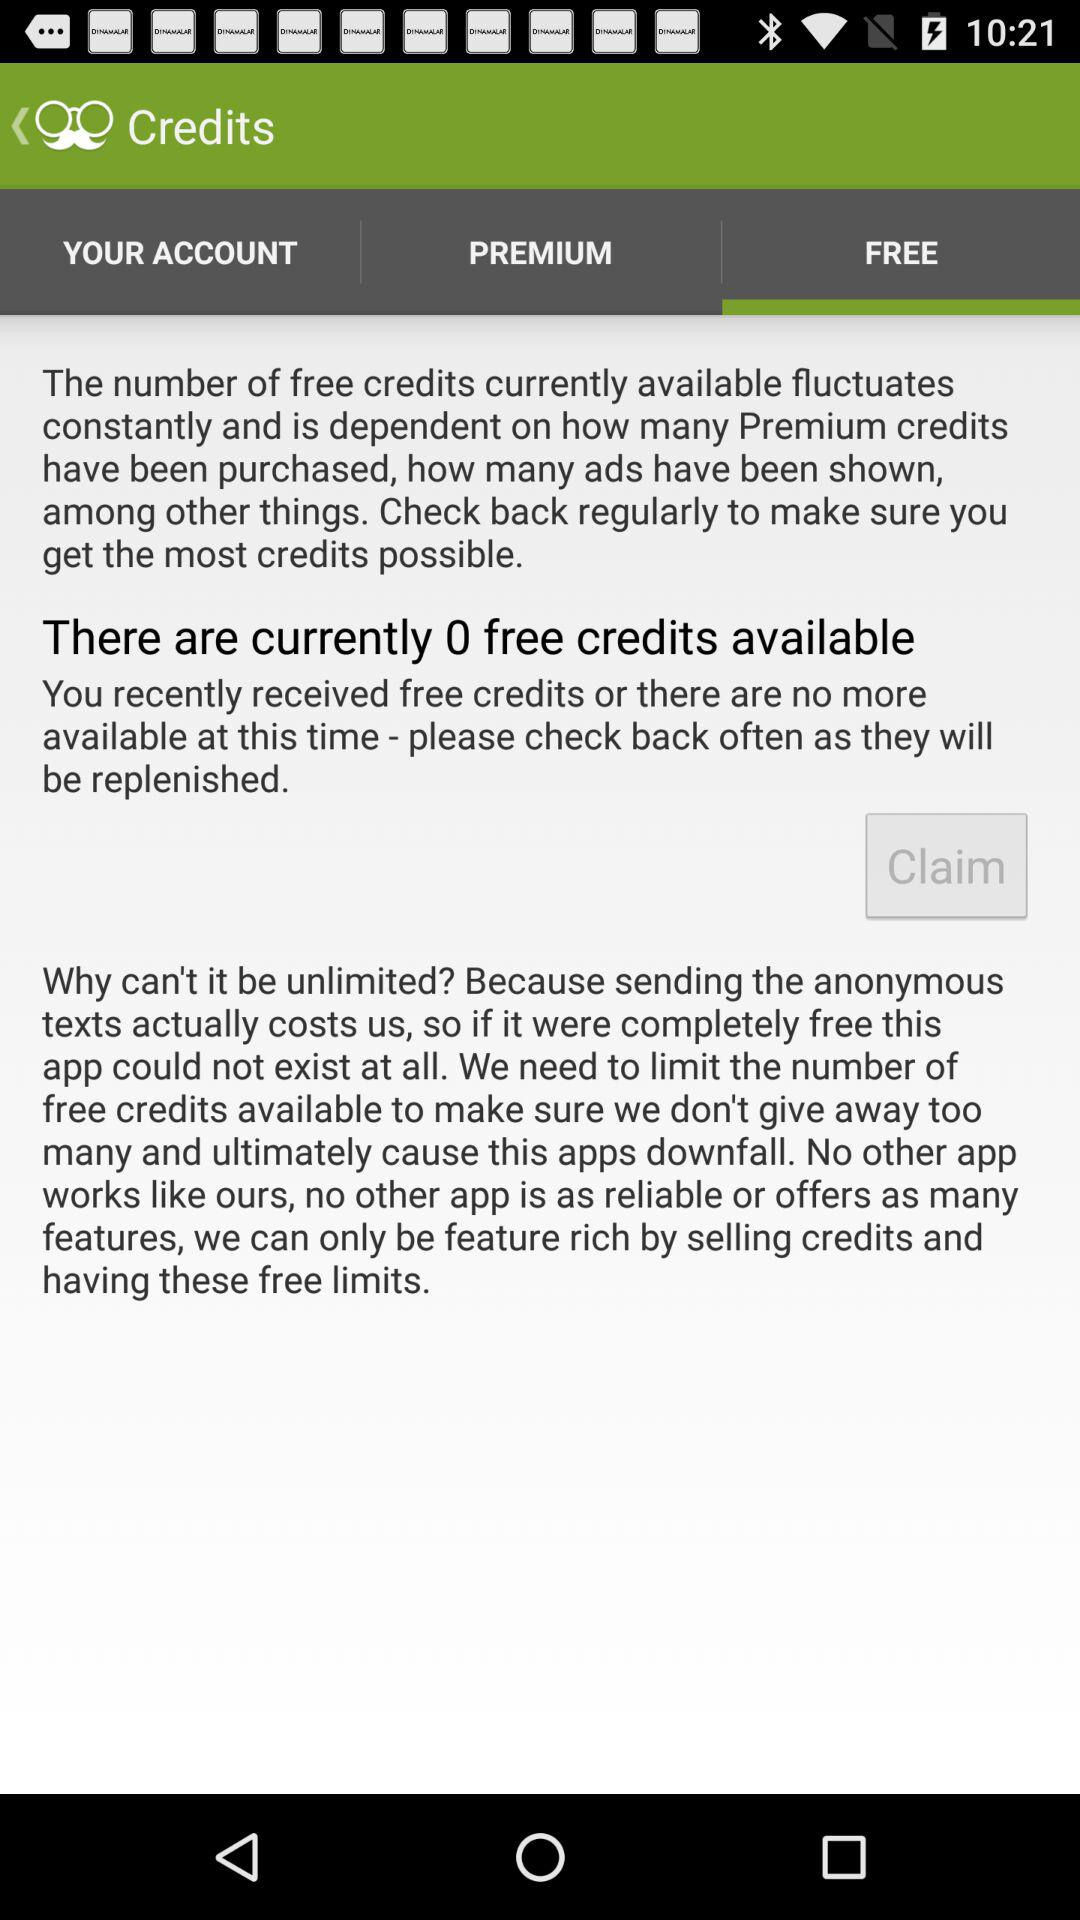How many free credits are available?
Answer the question using a single word or phrase. 0 